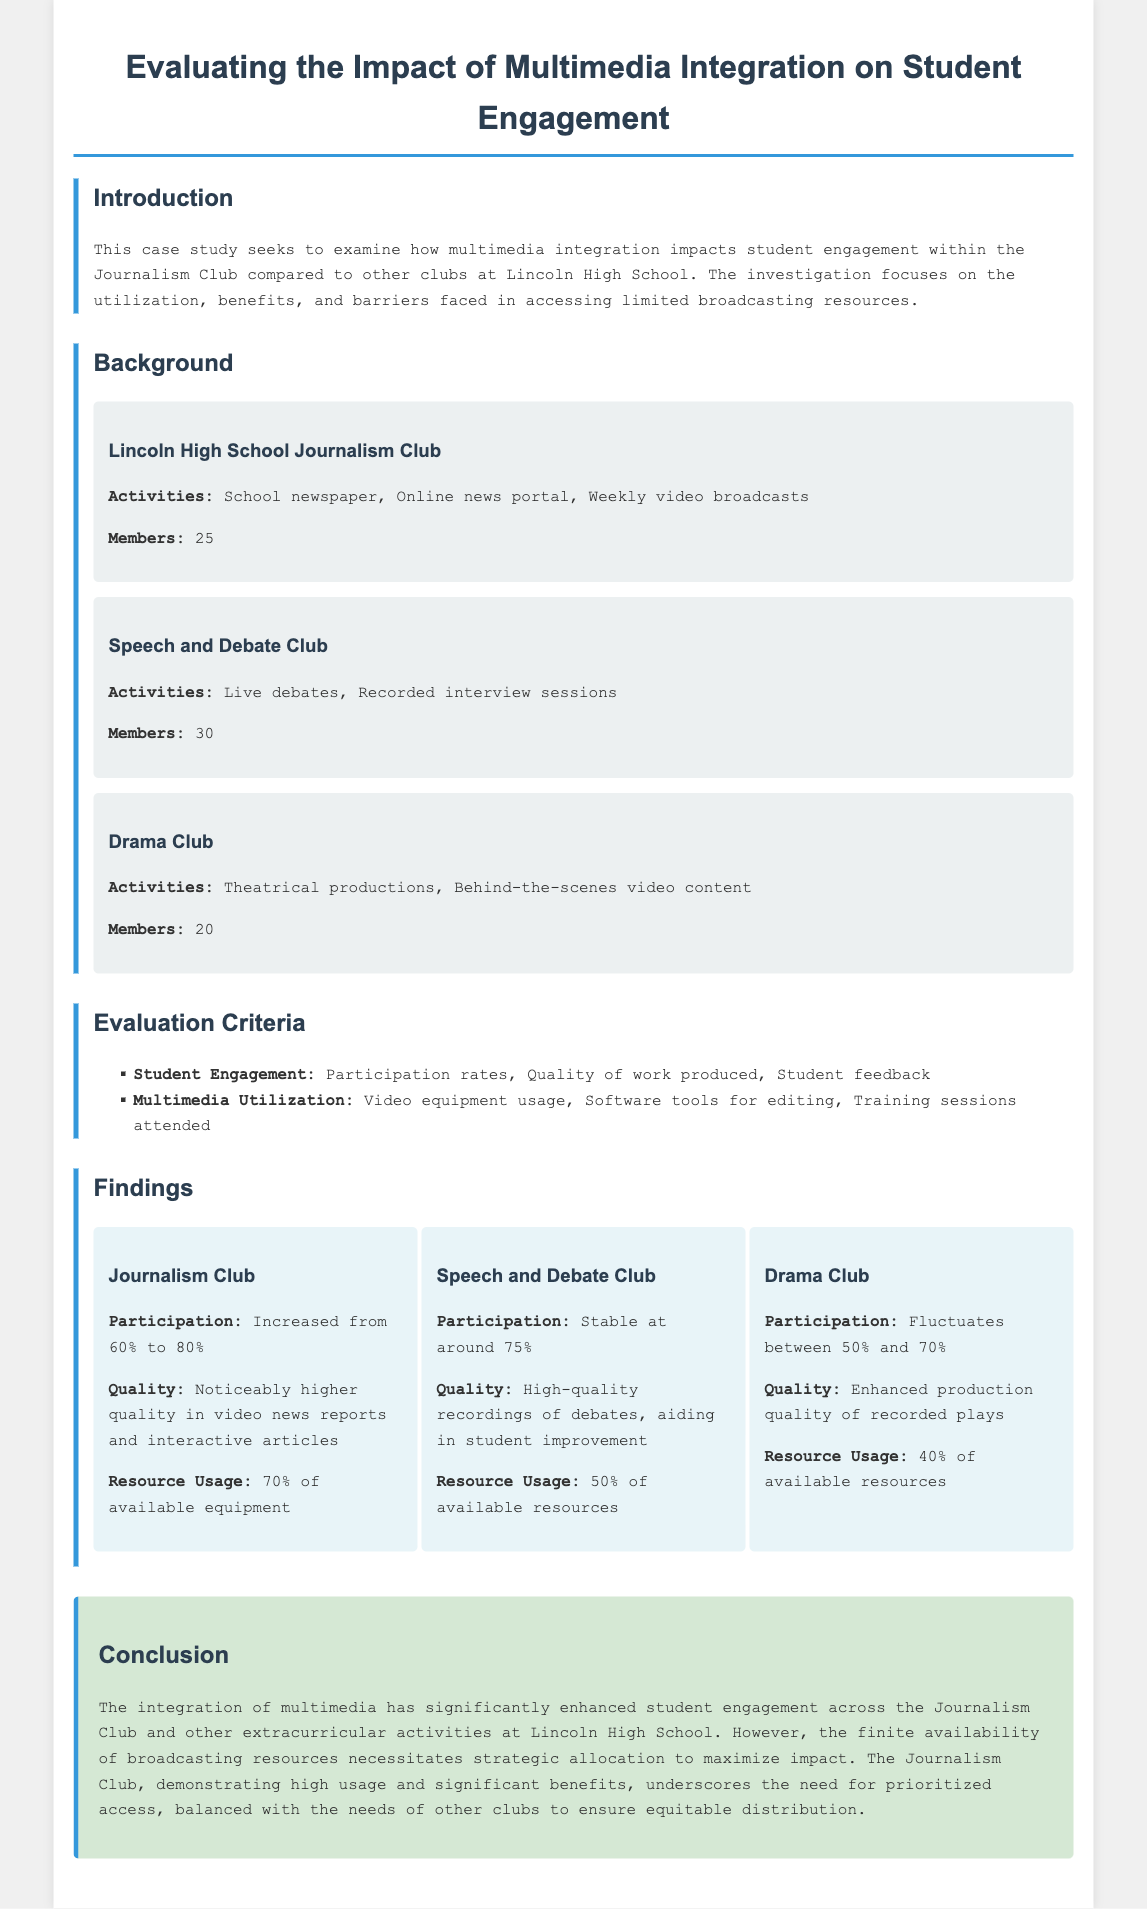what is the participation rate increase for the Journalism Club? The participation rate increased from 60% to 80% for the Journalism Club.
Answer: 80% how many members are in the Speech and Debate Club? The document states that there are 30 members in the Speech and Debate Club.
Answer: 30 what is one activity of the Drama Club? The Drama Club is involved in theatrical productions according to the document.
Answer: Theatrical productions which club had the highest resource usage percentage? The Journalism Club had the highest resource usage at 70% of available equipment.
Answer: 70% what is the quality improvement noted for the Speech and Debate Club? The Speech and Debate Club's involvement resulted in high-quality recordings of debates that aid student improvement.
Answer: High-quality recordings what is the conclusion about multimedia integration in student engagement? The conclusion emphasizes that multimedia integration has significantly enhanced student engagement.
Answer: Enhanced student engagement how many members are in the Journalism Club? The document states that there are 25 members in the Journalism Club.
Answer: 25 what percentage of available resources does the Drama Club use? The Drama Club uses 40% of available resources according to the findings.
Answer: 40% 